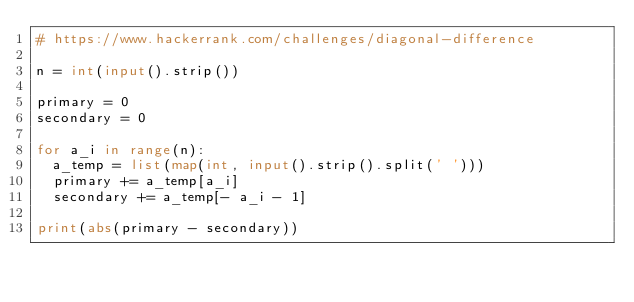<code> <loc_0><loc_0><loc_500><loc_500><_Python_># https://www.hackerrank.com/challenges/diagonal-difference

n = int(input().strip())

primary = 0
secondary = 0

for a_i in range(n):
  a_temp = list(map(int, input().strip().split(' ')))
  primary += a_temp[a_i]
  secondary += a_temp[- a_i - 1]

print(abs(primary - secondary))
</code> 